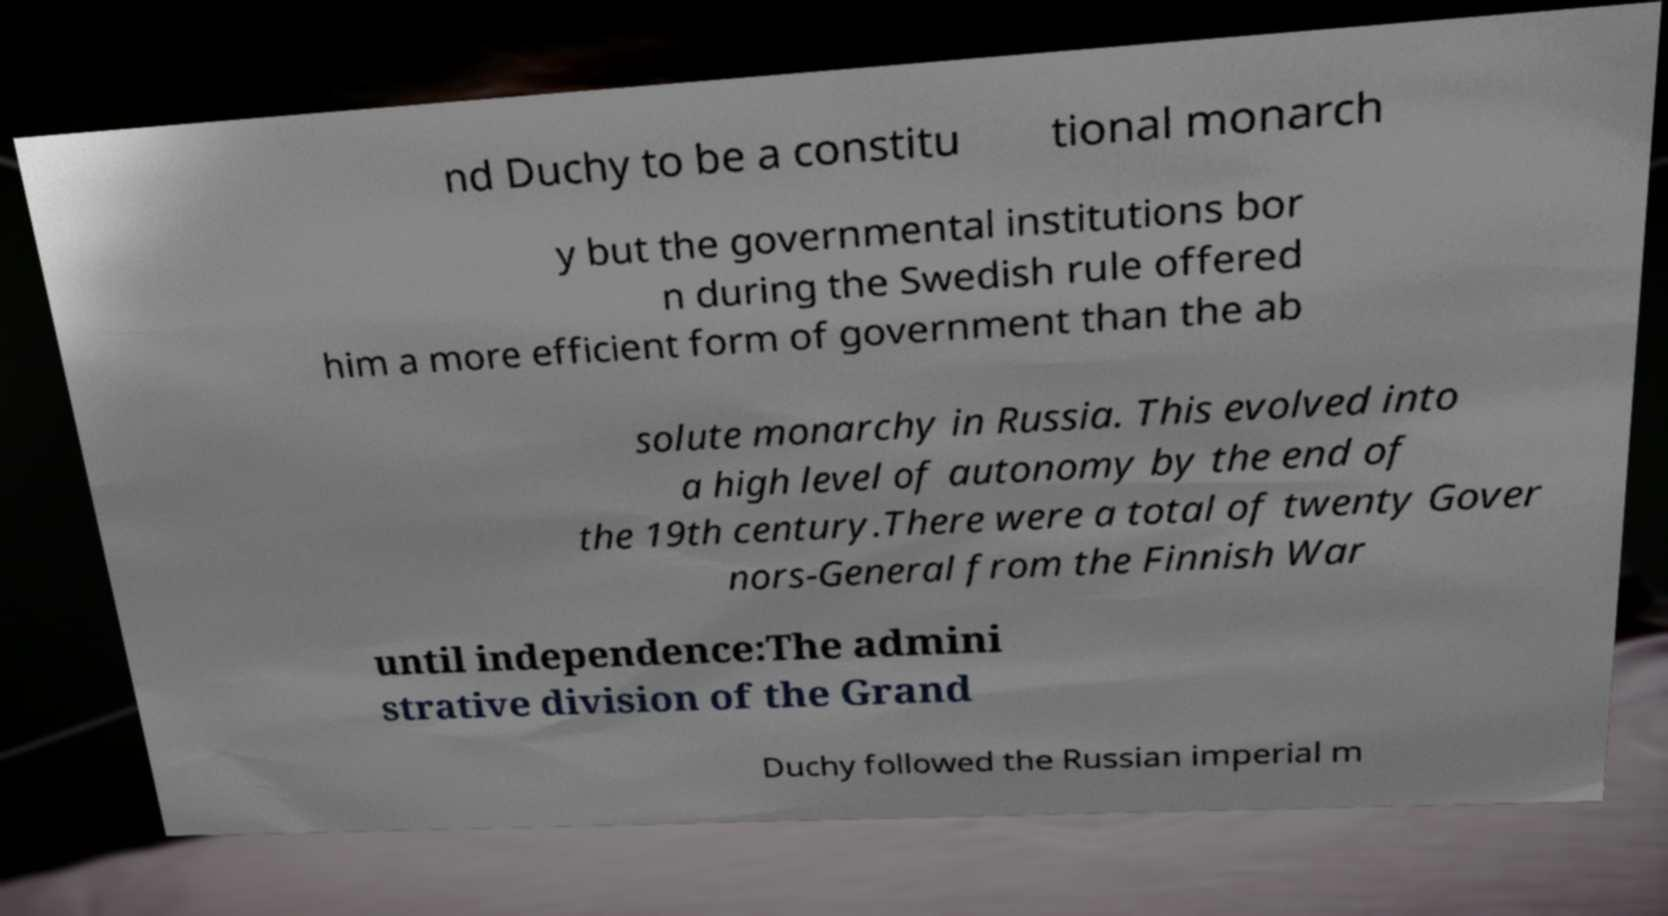Can you read and provide the text displayed in the image?This photo seems to have some interesting text. Can you extract and type it out for me? nd Duchy to be a constitu tional monarch y but the governmental institutions bor n during the Swedish rule offered him a more efficient form of government than the ab solute monarchy in Russia. This evolved into a high level of autonomy by the end of the 19th century.There were a total of twenty Gover nors-General from the Finnish War until independence:The admini strative division of the Grand Duchy followed the Russian imperial m 